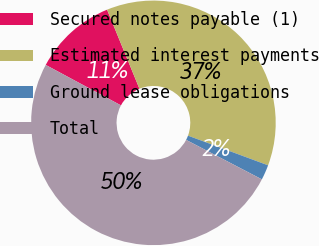<chart> <loc_0><loc_0><loc_500><loc_500><pie_chart><fcel>Secured notes payable (1)<fcel>Estimated interest payments<fcel>Ground lease obligations<fcel>Total<nl><fcel>10.96%<fcel>36.84%<fcel>2.0%<fcel>50.21%<nl></chart> 